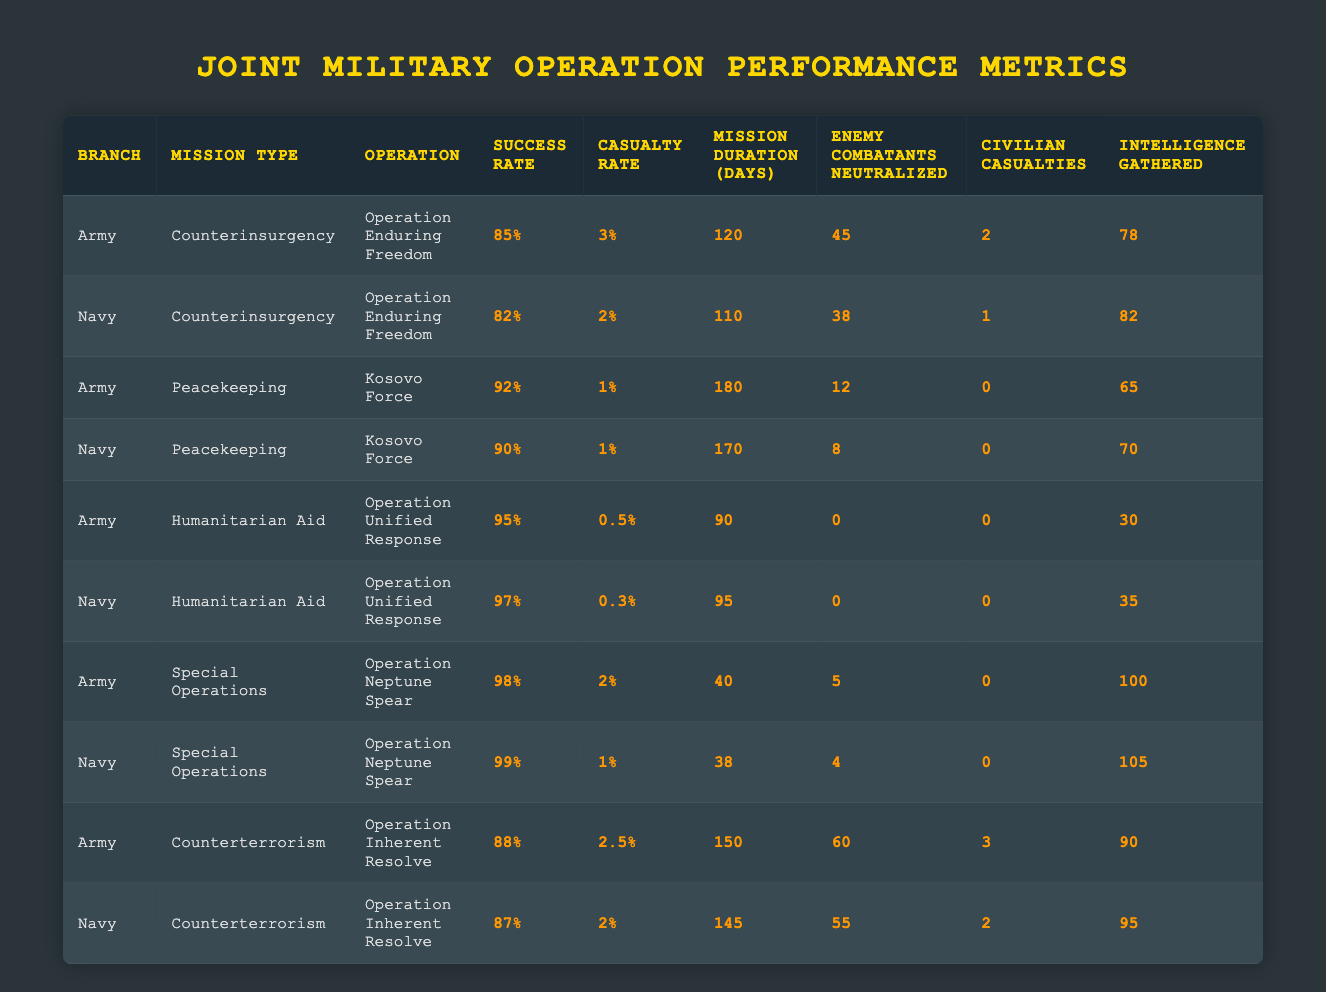What is the success rate of Operation Enduring Freedom conducted by the Army? The success rate of the Army in Operation Enduring Freedom can be found in the corresponding row for the Army under the mission type Counterinsurgency. It is listed as 85%.
Answer: 85% Which branch had a lower casualty rate during Counterterrorism missions? To find the branch with a lower casualty rate during Counterterrorism, compare the casualty rates from both the Army and Navy. The Army has a casualty rate of 2.5%, whereas the Navy has a casualty rate of 2%. Since 2% is less than 2.5%, the Navy had a lower casualty rate.
Answer: Navy What is the total number of enemy combatants neutralized in Peacekeeping missions by both branches? First, identify the number of enemy combatants neutralized in Peacekeeping missions: Army: 12, Navy: 8. Adding these gives a total of 12 + 8 = 20.
Answer: 20 Was there any civilian casualty in the Army's Humanitarian Aid operations? In the data for the Army's Humanitarian Aid operations, the number of civilian casualties is noted as 0. Therefore, the answer is yes, there were no civilian casualties.
Answer: Yes Which operation had the highest intelligence gathered? Check the intelligence gathered for each operation in the table. Operation Neptune Spear (Army) has 100, while Operation Neptune Spear (Navy) has 105. The highest intelligence gathered is from the Navy's Operation Neptune Spear.
Answer: Navy's Operation Neptune Spear What is the average mission duration for Humanitarian Aid missions? Gather the mission durations for Humanitarian Aid: Army: 90 days, Navy: 95 days. Add them (90 + 95 = 185) and divide by the number of missions (2) to get the average: 185 / 2 = 92.5 days.
Answer: 92.5 days Did the Navy's success rate in Counterinsurgency exceed that of the Army? The Army’s success rate in Counterinsurgency is 85%, while the Navy’s is 82%. Since 82% is less than 85%, the Navy did not exceed the Army's success rate.
Answer: No Which branch had the longest average mission duration across all missions? To find the longest average mission duration, calculate for both branches. Army: (120 + 180 + 90 + 40 + 150) / 5 = 116 days. Navy: (110 + 170 + 95 + 38 + 145) / 5 = 111.6 days. Since 116 days is greater than 111.6 days, the Army had the longest average mission duration.
Answer: Army 